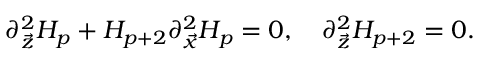Convert formula to latex. <formula><loc_0><loc_0><loc_500><loc_500>\partial _ { \vec { z } } ^ { 2 } H _ { p } + H _ { p + 2 } \partial _ { \vec { x } } ^ { 2 } H _ { p } = 0 , \quad p a r t i a l _ { \vec { z } } ^ { 2 } H _ { p + 2 } = 0 .</formula> 